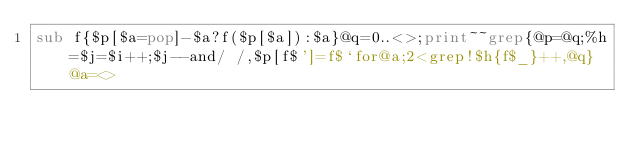<code> <loc_0><loc_0><loc_500><loc_500><_Perl_>sub f{$p[$a=pop]-$a?f($p[$a]):$a}@q=0..<>;print~~grep{@p=@q;%h=$j=$i++;$j--and/ /,$p[f$']=f$`for@a;2<grep!$h{f$_}++,@q}@a=<></code> 